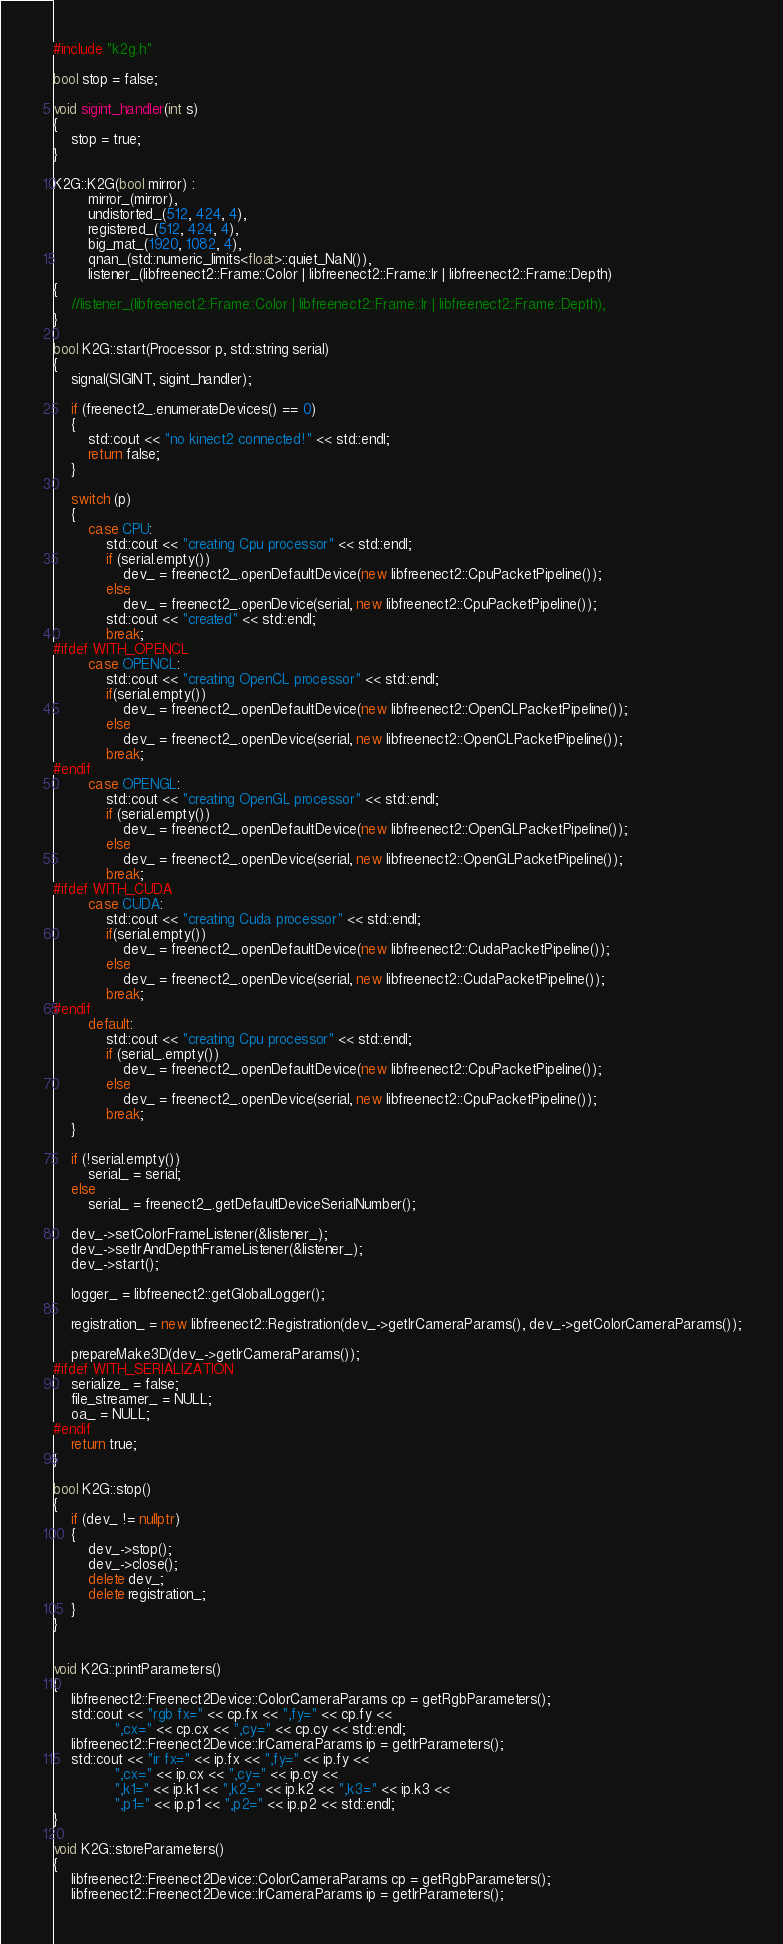Convert code to text. <code><loc_0><loc_0><loc_500><loc_500><_C++_>#include "k2g.h"

bool stop = false;

void sigint_handler(int s)
{
    stop = true;
}

K2G::K2G(bool mirror) :
        mirror_(mirror),
        undistorted_(512, 424, 4),
        registered_(512, 424, 4),
        big_mat_(1920, 1082, 4),
        qnan_(std::numeric_limits<float>::quiet_NaN()),
        listener_(libfreenect2::Frame::Color | libfreenect2::Frame::Ir | libfreenect2::Frame::Depth)
{
    //listener_(libfreenect2::Frame::Color | libfreenect2::Frame::Ir | libfreenect2::Frame::Depth),
}

bool K2G::start(Processor p, std::string serial)
{
    signal(SIGINT, sigint_handler);

    if (freenect2_.enumerateDevices() == 0)
    {
        std::cout << "no kinect2 connected!" << std::endl;
        return false;
    }

    switch (p)
    {
        case CPU:
            std::cout << "creating Cpu processor" << std::endl;
            if (serial.empty())
                dev_ = freenect2_.openDefaultDevice(new libfreenect2::CpuPacketPipeline());
            else
                dev_ = freenect2_.openDevice(serial, new libfreenect2::CpuPacketPipeline());
            std::cout << "created" << std::endl;
            break;
#ifdef WITH_OPENCL
        case OPENCL:
            std::cout << "creating OpenCL processor" << std::endl;
            if(serial.empty())
                dev_ = freenect2_.openDefaultDevice(new libfreenect2::OpenCLPacketPipeline());
            else
                dev_ = freenect2_.openDevice(serial, new libfreenect2::OpenCLPacketPipeline());
            break;
#endif
        case OPENGL:
            std::cout << "creating OpenGL processor" << std::endl;
            if (serial.empty())
                dev_ = freenect2_.openDefaultDevice(new libfreenect2::OpenGLPacketPipeline());
            else
                dev_ = freenect2_.openDevice(serial, new libfreenect2::OpenGLPacketPipeline());
            break;
#ifdef WITH_CUDA
        case CUDA:
            std::cout << "creating Cuda processor" << std::endl;
            if(serial.empty())
                dev_ = freenect2_.openDefaultDevice(new libfreenect2::CudaPacketPipeline());
            else
                dev_ = freenect2_.openDevice(serial, new libfreenect2::CudaPacketPipeline());
            break;
#endif
        default:
            std::cout << "creating Cpu processor" << std::endl;
            if (serial_.empty())
                dev_ = freenect2_.openDefaultDevice(new libfreenect2::CpuPacketPipeline());
            else
                dev_ = freenect2_.openDevice(serial, new libfreenect2::CpuPacketPipeline());
            break;
    }

    if (!serial.empty())
        serial_ = serial;
    else
        serial_ = freenect2_.getDefaultDeviceSerialNumber();

    dev_->setColorFrameListener(&listener_);
    dev_->setIrAndDepthFrameListener(&listener_);
    dev_->start();

    logger_ = libfreenect2::getGlobalLogger();

    registration_ = new libfreenect2::Registration(dev_->getIrCameraParams(), dev_->getColorCameraParams());

    prepareMake3D(dev_->getIrCameraParams());
#ifdef WITH_SERIALIZATION
    serialize_ = false;
    file_streamer_ = NULL;
    oa_ = NULL;
#endif
    return true;
}

bool K2G::stop()
{
    if (dev_ != nullptr)
    {
        dev_->stop();
        dev_->close();
        delete dev_;
        delete registration_;
    }
}


void K2G::printParameters()
{
    libfreenect2::Freenect2Device::ColorCameraParams cp = getRgbParameters();
    std::cout << "rgb fx=" << cp.fx << ",fy=" << cp.fy <<
              ",cx=" << cp.cx << ",cy=" << cp.cy << std::endl;
    libfreenect2::Freenect2Device::IrCameraParams ip = getIrParameters();
    std::cout << "ir fx=" << ip.fx << ",fy=" << ip.fy <<
              ",cx=" << ip.cx << ",cy=" << ip.cy <<
              ",k1=" << ip.k1 << ",k2=" << ip.k2 << ",k3=" << ip.k3 <<
              ",p1=" << ip.p1 << ",p2=" << ip.p2 << std::endl;
}

void K2G::storeParameters()
{
    libfreenect2::Freenect2Device::ColorCameraParams cp = getRgbParameters();
    libfreenect2::Freenect2Device::IrCameraParams ip = getIrParameters();
</code> 